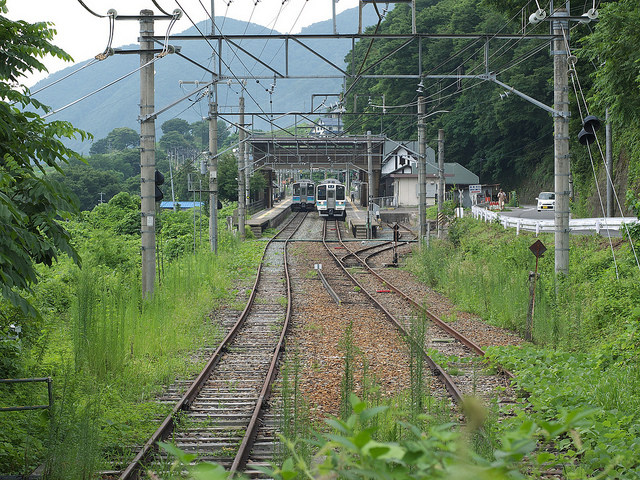What features in the image could indicate that the trains run frequently? The tracks appear to be well-maintained, indicating regular use. Moreover, the overhead wires are an integral part of an electric train system which typically supports a high frequency of train services. Additionally, the presence of two trains in the photo suggests that this line is in active service. 